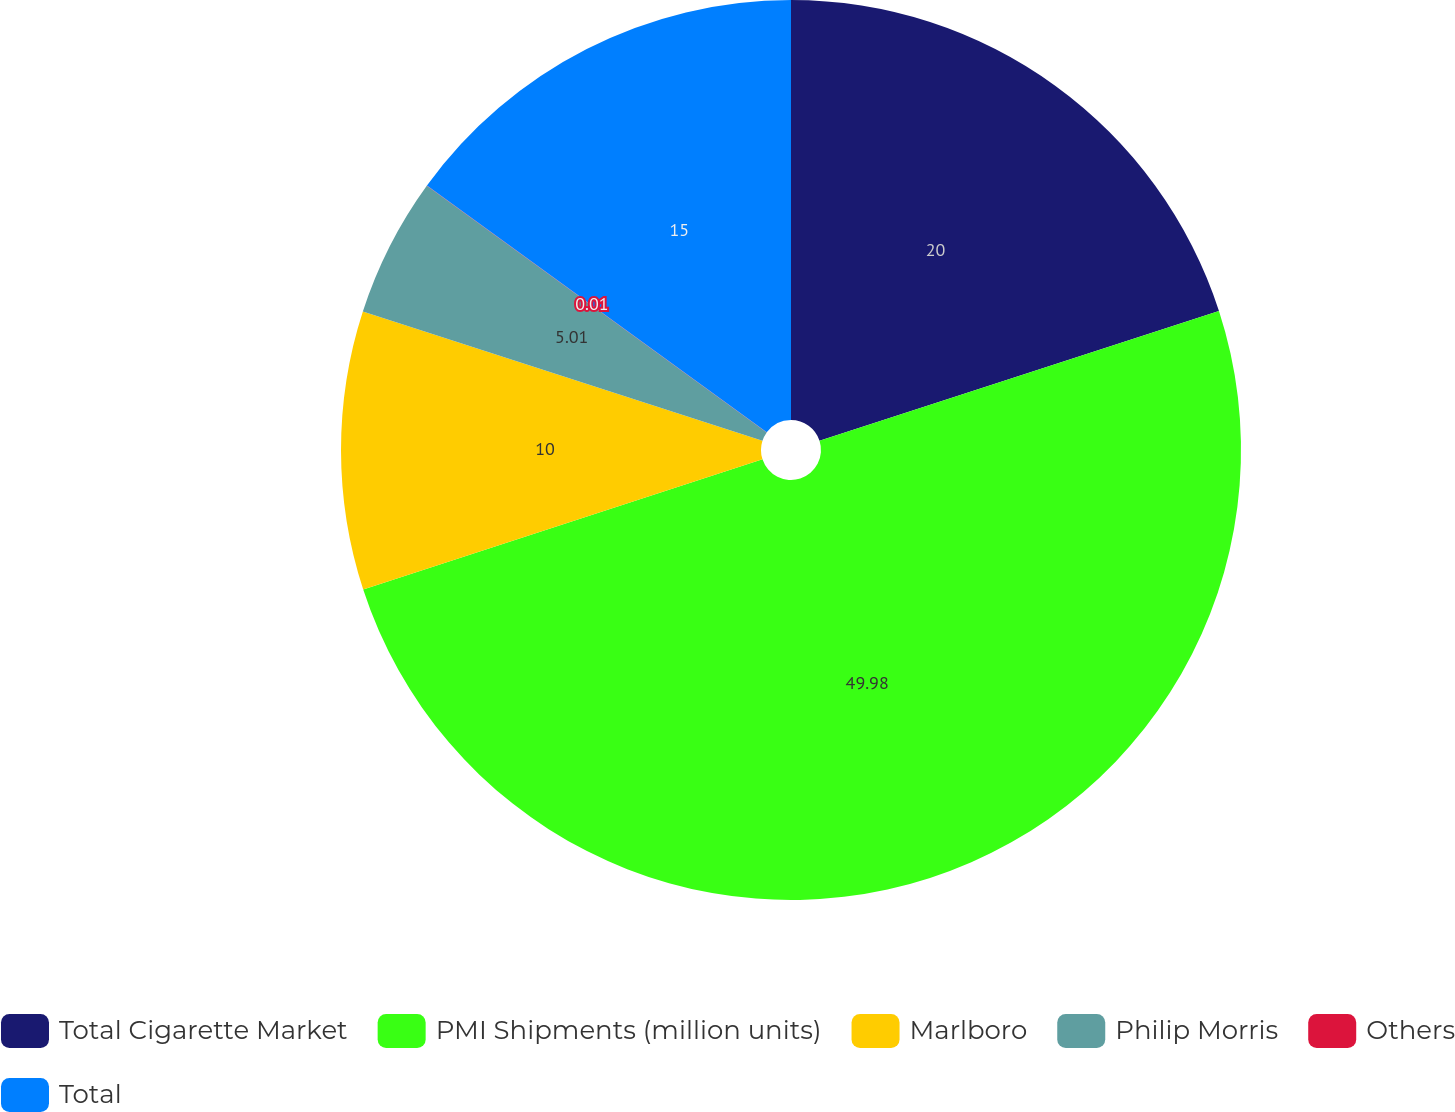Convert chart to OTSL. <chart><loc_0><loc_0><loc_500><loc_500><pie_chart><fcel>Total Cigarette Market<fcel>PMI Shipments (million units)<fcel>Marlboro<fcel>Philip Morris<fcel>Others<fcel>Total<nl><fcel>20.0%<fcel>49.98%<fcel>10.0%<fcel>5.01%<fcel>0.01%<fcel>15.0%<nl></chart> 